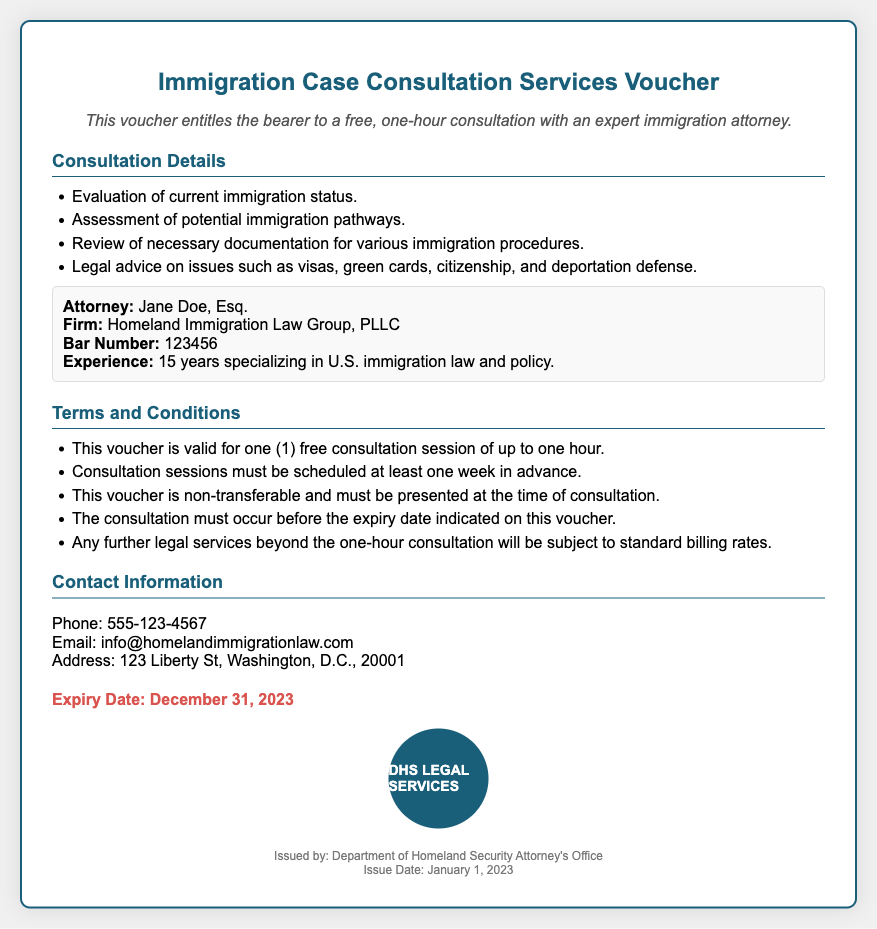What is the name of the attorney? The voucher lists the attorney's name as Jane Doe.
Answer: Jane Doe What is the expiry date of the voucher? The document states that the voucher expires on December 31, 2023.
Answer: December 31, 2023 How many years of experience does the attorney have? The document indicates the attorney has 15 years of experience.
Answer: 15 years What type of law does the attorney specialize in? The document specifies that the attorney specializes in U.S. immigration law and policy.
Answer: U.S. immigration law Is the consultation session transferable? The terms indicate that the voucher is non-transferable.
Answer: Non-transferable What must be done at least one week in advance? The terms require that consultation sessions be scheduled at least one week in advance.
Answer: Consultation sessions What is the contact phone number? The document provides the phone number as 555-123-4567.
Answer: 555-123-4567 What is included in the consultation? The document lists evaluation of current immigration status as part of the consultation.
Answer: Evaluation of current immigration status What is the issuing organization? The footer of the voucher states it was issued by the Department of Homeland Security Attorney's Office.
Answer: Department of Homeland Security Attorney's Office 